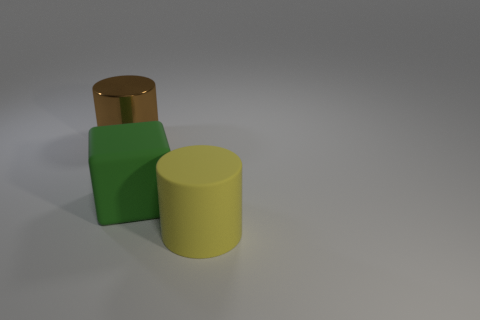There is a thing that is made of the same material as the large green block; what shape is it?
Offer a terse response. Cylinder. What is the cube that is to the left of the big cylinder that is right of the large brown thing behind the green block made of?
Your response must be concise. Rubber. There is a rubber cylinder; is its size the same as the thing behind the green rubber cube?
Your answer should be very brief. Yes. What material is the large yellow thing that is the same shape as the brown object?
Your answer should be very brief. Rubber. How big is the matte thing to the right of the big matte thing on the left side of the cylinder right of the big brown shiny thing?
Provide a short and direct response. Large. What material is the cube that is behind the large cylinder that is to the right of the big brown metallic cylinder?
Your response must be concise. Rubber. Does the thing behind the large green rubber block have the same shape as the matte thing to the right of the rubber cube?
Your answer should be very brief. Yes. Is the number of large green rubber cubes that are in front of the shiny cylinder the same as the number of yellow cylinders?
Provide a succinct answer. Yes. Are there any green matte blocks that are in front of the large cylinder on the left side of the rubber cylinder?
Provide a succinct answer. Yes. Is there anything else that is the same color as the big shiny thing?
Give a very brief answer. No. 